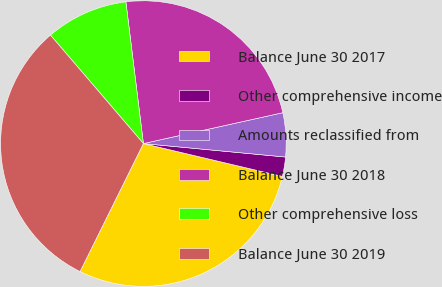Convert chart to OTSL. <chart><loc_0><loc_0><loc_500><loc_500><pie_chart><fcel>Balance June 30 2017<fcel>Other comprehensive income<fcel>Amounts reclassified from<fcel>Balance June 30 2018<fcel>Other comprehensive loss<fcel>Balance June 30 2019<nl><fcel>28.62%<fcel>2.19%<fcel>4.97%<fcel>23.49%<fcel>9.32%<fcel>31.41%<nl></chart> 